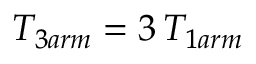<formula> <loc_0><loc_0><loc_500><loc_500>T _ { 3 a r m } = 3 \, T _ { 1 a r m }</formula> 